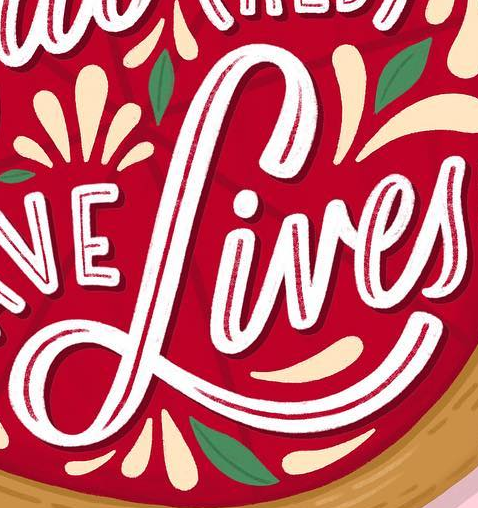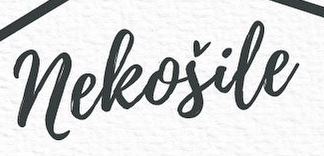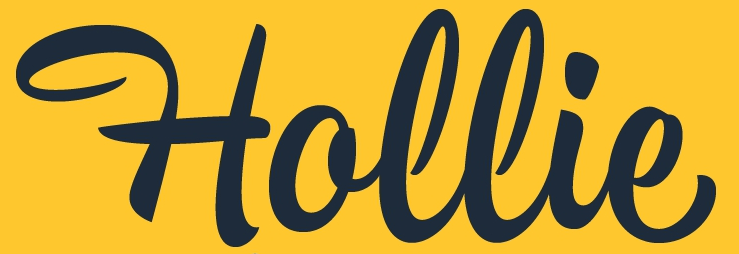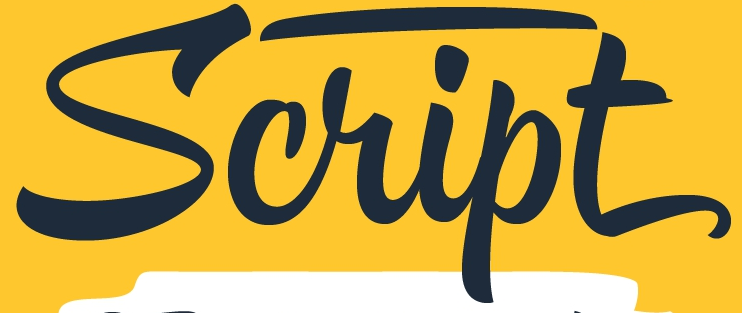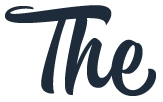Read the text content from these images in order, separated by a semicolon. Lives; neleošile; Hollie; Script; The 